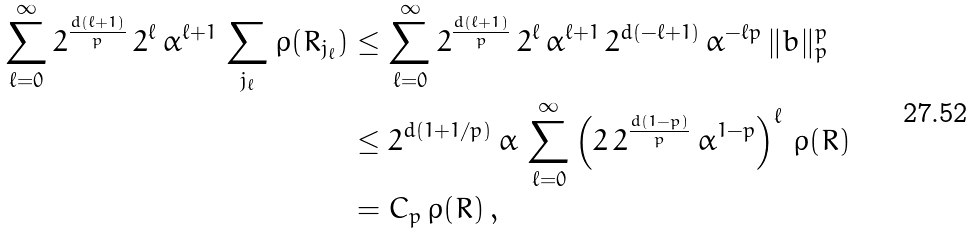Convert formula to latex. <formula><loc_0><loc_0><loc_500><loc_500>\sum _ { \ell = 0 } ^ { \infty } 2 ^ { \frac { d ( \ell + 1 ) } { p } } \, 2 ^ { \ell } \, \alpha ^ { \ell + 1 } \, \sum _ { j _ { \ell } } \rho ( R _ { j _ { \ell } } ) & \leq \sum _ { \ell = 0 } ^ { \infty } 2 ^ { \frac { d ( \ell + 1 ) } { p } } \, 2 ^ { \ell } \, \alpha ^ { \ell + 1 } \, 2 ^ { d ( - \ell + 1 ) } \, \alpha ^ { - \ell p } \, \| b \| ^ { p } _ { p } \\ & \leq 2 ^ { d ( 1 + 1 / p ) } \, \alpha \, \sum _ { \ell = 0 } ^ { \infty } \left ( 2 \, 2 ^ { \frac { d ( 1 - p ) } { p } } \, \alpha ^ { 1 - p } \right ) ^ { \ell } \, \rho ( R ) \\ & = C _ { p } \, \rho ( R ) \, ,</formula> 